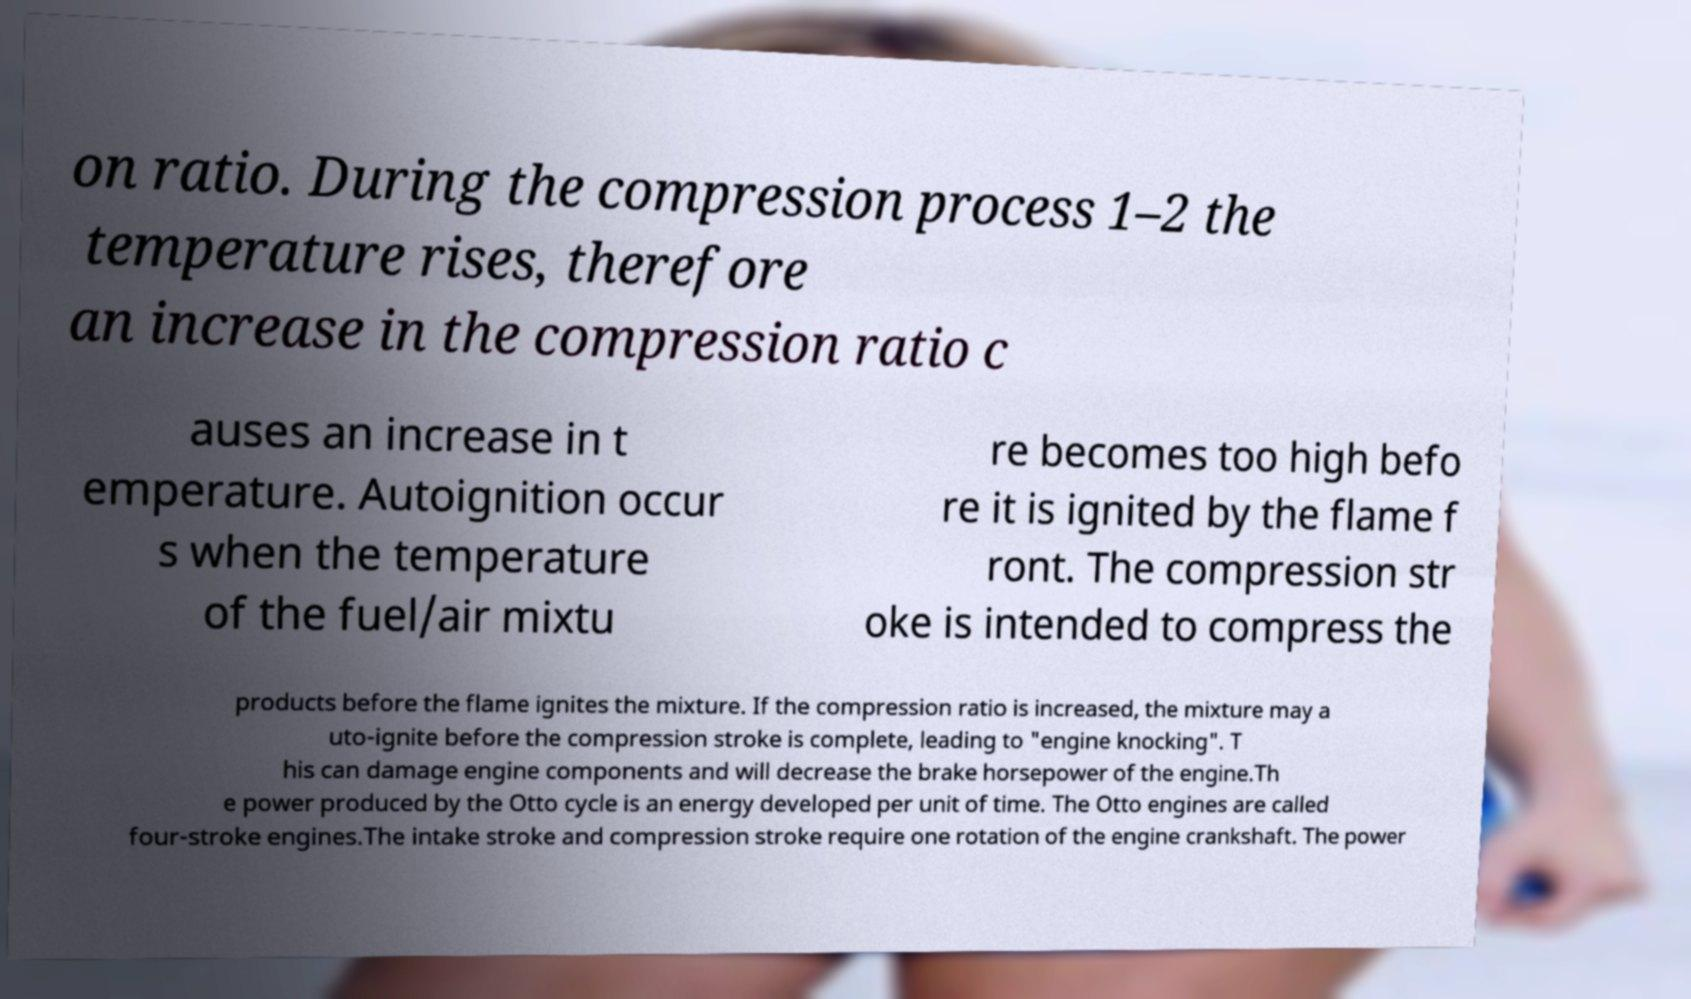Can you accurately transcribe the text from the provided image for me? on ratio. During the compression process 1–2 the temperature rises, therefore an increase in the compression ratio c auses an increase in t emperature. Autoignition occur s when the temperature of the fuel/air mixtu re becomes too high befo re it is ignited by the flame f ront. The compression str oke is intended to compress the products before the flame ignites the mixture. If the compression ratio is increased, the mixture may a uto-ignite before the compression stroke is complete, leading to "engine knocking". T his can damage engine components and will decrease the brake horsepower of the engine.Th e power produced by the Otto cycle is an energy developed per unit of time. The Otto engines are called four-stroke engines.The intake stroke and compression stroke require one rotation of the engine crankshaft. The power 